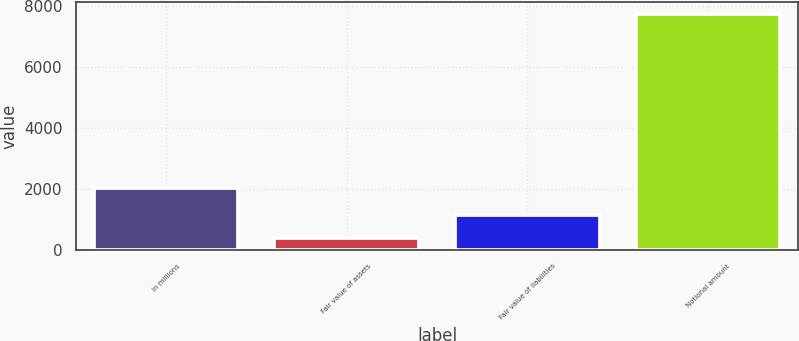<chart> <loc_0><loc_0><loc_500><loc_500><bar_chart><fcel>in millions<fcel>Fair value of assets<fcel>Fair value of liabilities<fcel>Notional amount<nl><fcel>2014<fcel>390<fcel>1124.5<fcel>7735<nl></chart> 